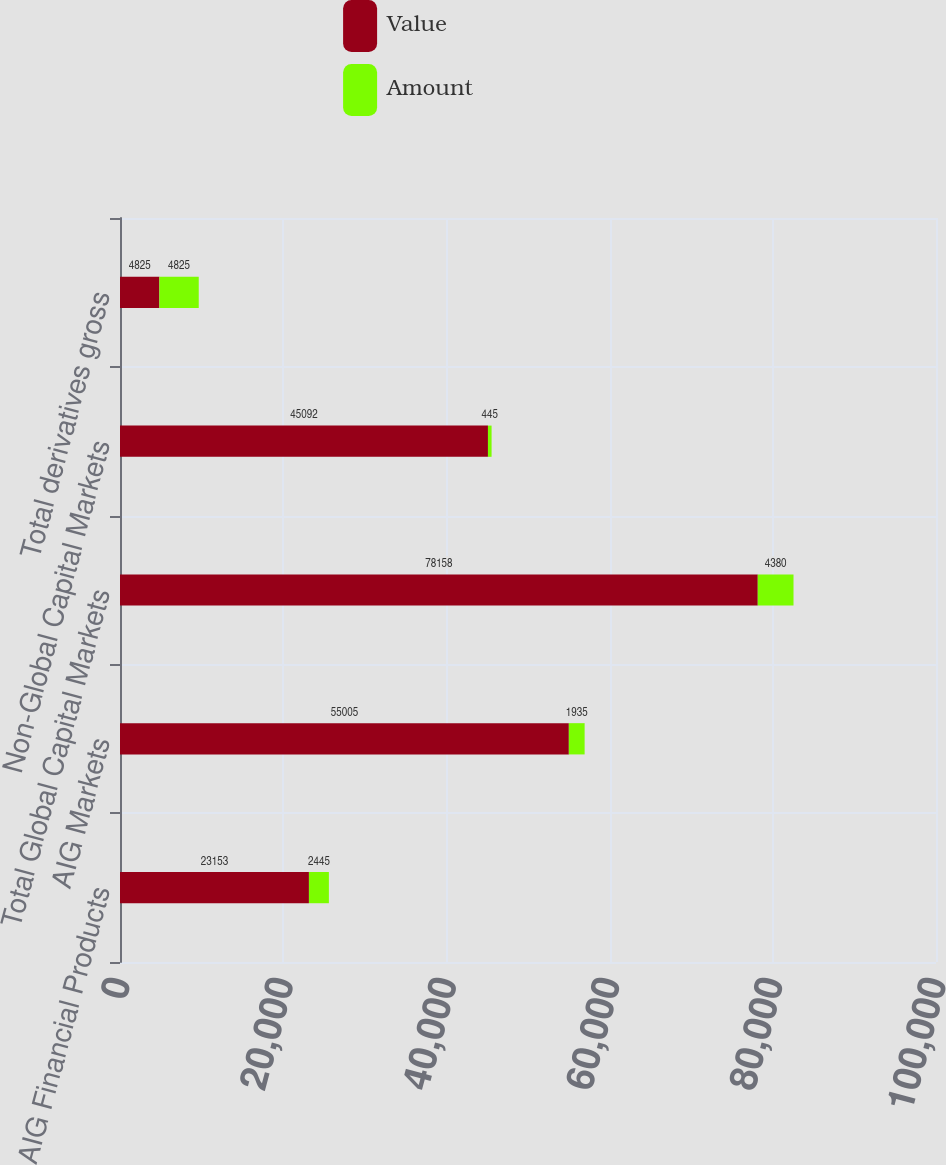Convert chart to OTSL. <chart><loc_0><loc_0><loc_500><loc_500><stacked_bar_chart><ecel><fcel>AIG Financial Products<fcel>AIG Markets<fcel>Total Global Capital Markets<fcel>Non-Global Capital Markets<fcel>Total derivatives gross<nl><fcel>Value<fcel>23153<fcel>55005<fcel>78158<fcel>45092<fcel>4825<nl><fcel>Amount<fcel>2445<fcel>1935<fcel>4380<fcel>445<fcel>4825<nl></chart> 